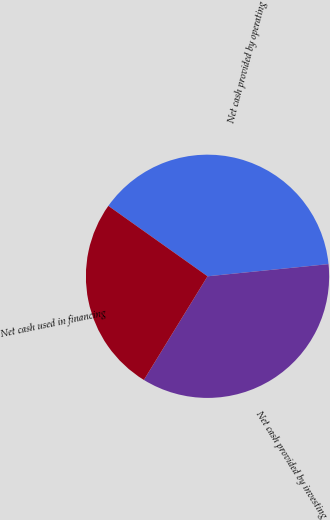<chart> <loc_0><loc_0><loc_500><loc_500><pie_chart><fcel>Net cash provided by operating<fcel>Net cash provided by investing<fcel>Net cash used in financing<nl><fcel>38.58%<fcel>35.36%<fcel>26.06%<nl></chart> 